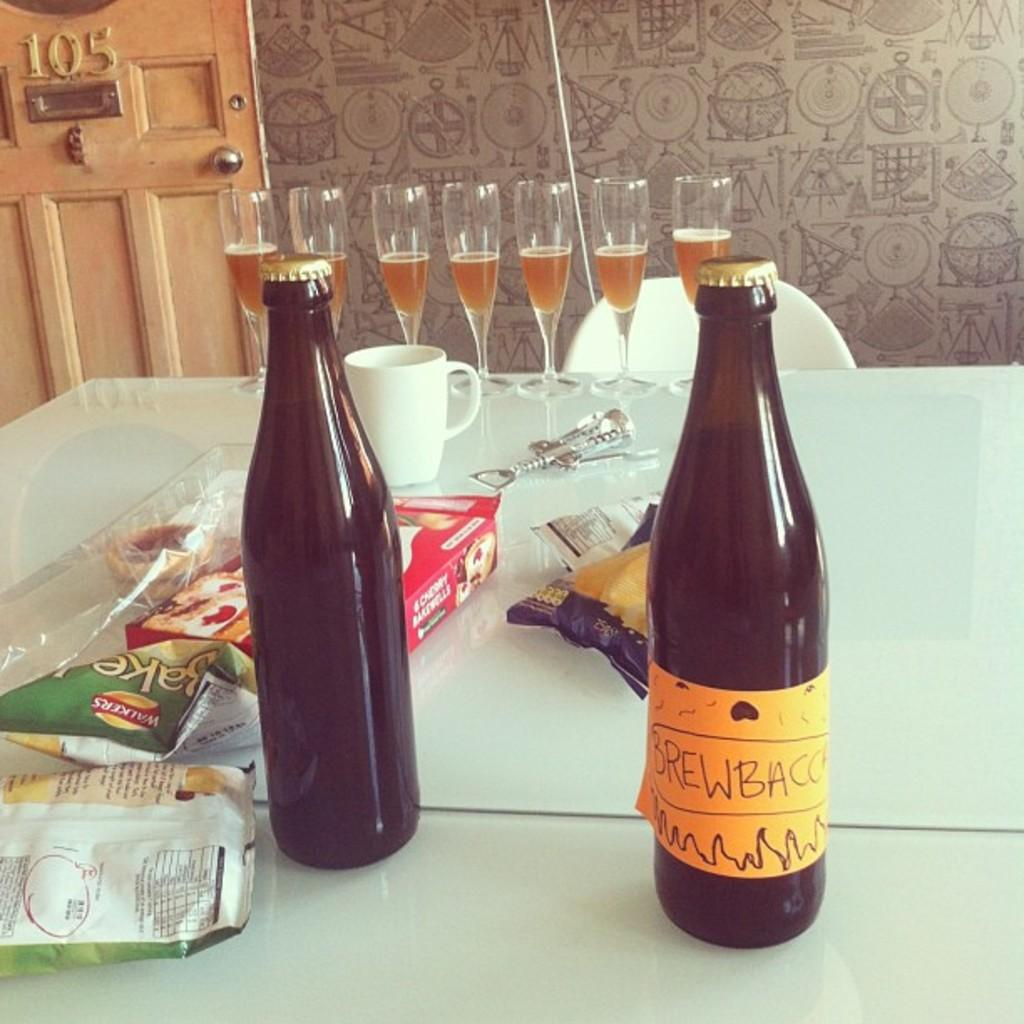<image>
Share a concise interpretation of the image provided. Two brown bottles with a handwritten label that says Brewbacc on a table with half full glasses and bags of chips. 